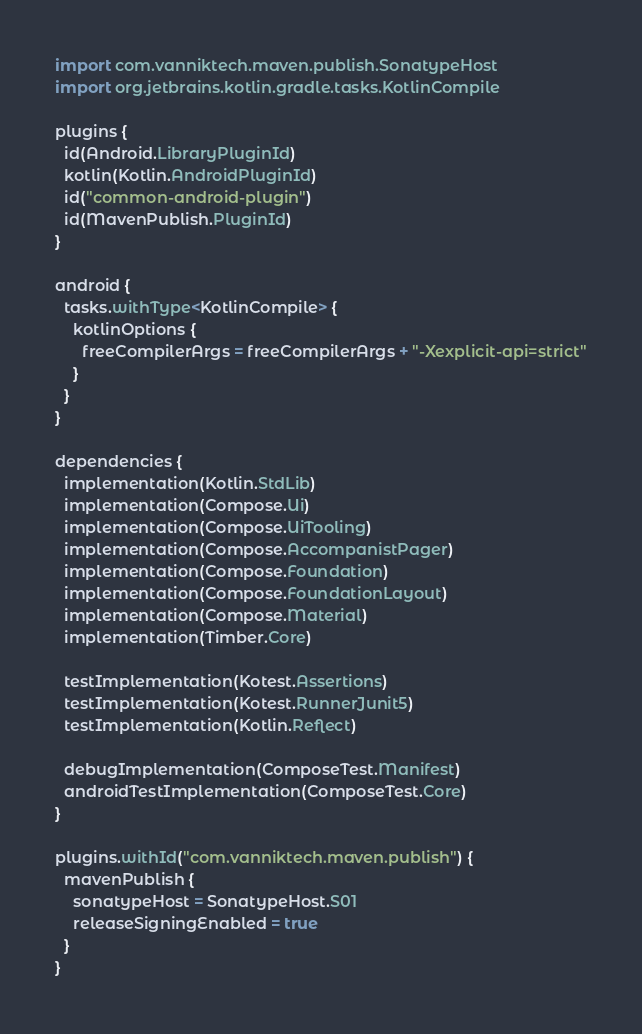Convert code to text. <code><loc_0><loc_0><loc_500><loc_500><_Kotlin_>import com.vanniktech.maven.publish.SonatypeHost
import org.jetbrains.kotlin.gradle.tasks.KotlinCompile

plugins {
  id(Android.LibraryPluginId)
  kotlin(Kotlin.AndroidPluginId)
  id("common-android-plugin")
  id(MavenPublish.PluginId)
}

android {
  tasks.withType<KotlinCompile> {
    kotlinOptions {
      freeCompilerArgs = freeCompilerArgs + "-Xexplicit-api=strict"
    }
  }
}

dependencies {
  implementation(Kotlin.StdLib)
  implementation(Compose.Ui)
  implementation(Compose.UiTooling)
  implementation(Compose.AccompanistPager)
  implementation(Compose.Foundation)
  implementation(Compose.FoundationLayout)
  implementation(Compose.Material)
  implementation(Timber.Core)

  testImplementation(Kotest.Assertions)
  testImplementation(Kotest.RunnerJunit5)
  testImplementation(Kotlin.Reflect)

  debugImplementation(ComposeTest.Manifest)
  androidTestImplementation(ComposeTest.Core)
}

plugins.withId("com.vanniktech.maven.publish") {
  mavenPublish {
    sonatypeHost = SonatypeHost.S01
    releaseSigningEnabled = true
  }
}
</code> 